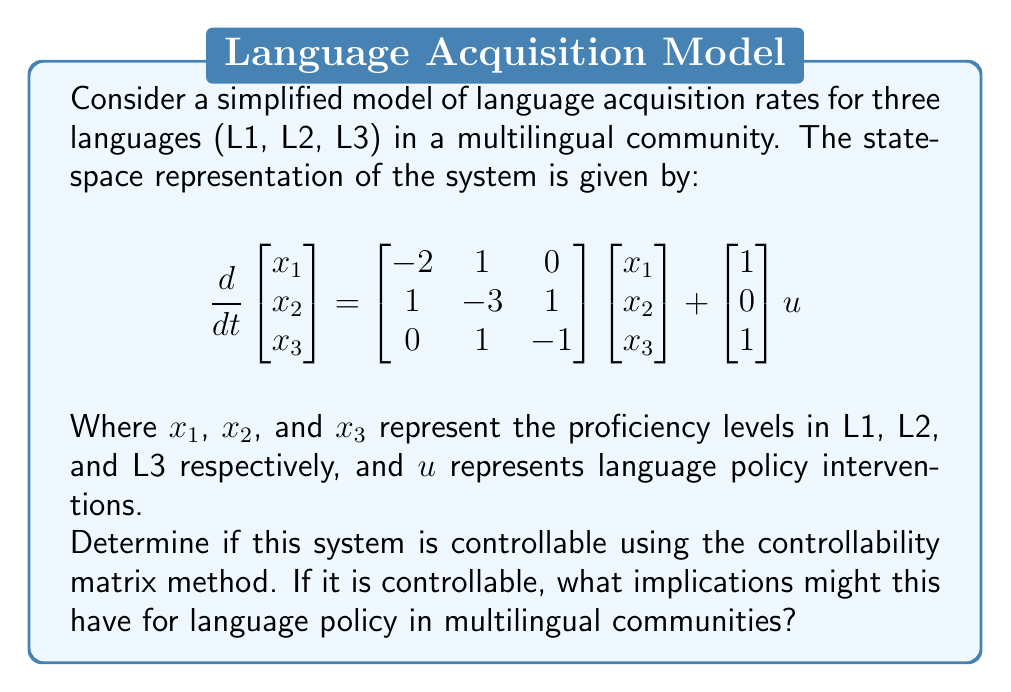What is the answer to this math problem? To determine the controllability of the system, we need to calculate the controllability matrix and check its rank. The steps are as follows:

1. Identify the system matrices:
   $A = \begin{bmatrix} -2 & 1 & 0 \\ 1 & -3 & 1 \\ 0 & 1 & -1 \end{bmatrix}$ and $B = \begin{bmatrix} 1 \\ 0 \\ 1 \end{bmatrix}$

2. Calculate the controllability matrix $C = [B \quad AB \quad A^2B]$:

   $AB = \begin{bmatrix} -2 & 1 & 0 \\ 1 & -3 & 1 \\ 0 & 1 & -1 \end{bmatrix}\begin{bmatrix} 1 \\ 0 \\ 1 \end{bmatrix} = \begin{bmatrix} -2 \\ -2 \\ -1 \end{bmatrix}$

   $A^2B = A(AB) = \begin{bmatrix} -2 & 1 & 0 \\ 1 & -3 & 1 \\ 0 & 1 & -1 \end{bmatrix}\begin{bmatrix} -2 \\ -2 \\ -1 \end{bmatrix} = \begin{bmatrix} 2 \\ 3 \\ 1 \end{bmatrix}$

   Therefore, $C = \begin{bmatrix} 1 & -2 & 2 \\ 0 & -2 & 3 \\ 1 & -1 & 1 \end{bmatrix}$

3. Calculate the rank of the controllability matrix:
   The matrix C has three linearly independent columns, so its rank is 3.

4. Compare the rank of C with the number of state variables (3):
   Since rank(C) = 3 = number of state variables, the system is controllable.

Implications for language policy:
Controllability implies that it's theoretically possible to steer the language proficiency levels from any initial state to any desired final state within finite time through appropriate policy interventions. This suggests that carefully designed language policies could effectively influence the acquisition rates of different languages in multilingual communities, potentially allowing policymakers to promote linguistic diversity or achieve specific language proficiency goals.
Answer: The system is controllable. Rank(C) = 3. 